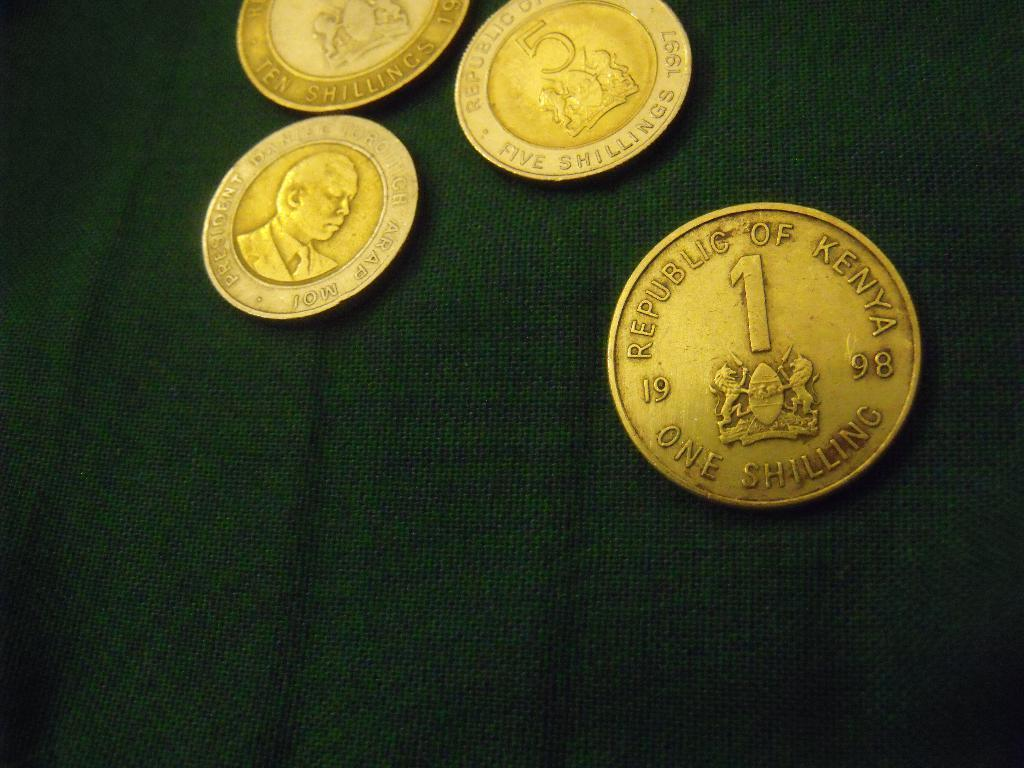<image>
Offer a succinct explanation of the picture presented. several kenyan coins are laying on a piece of fabric 